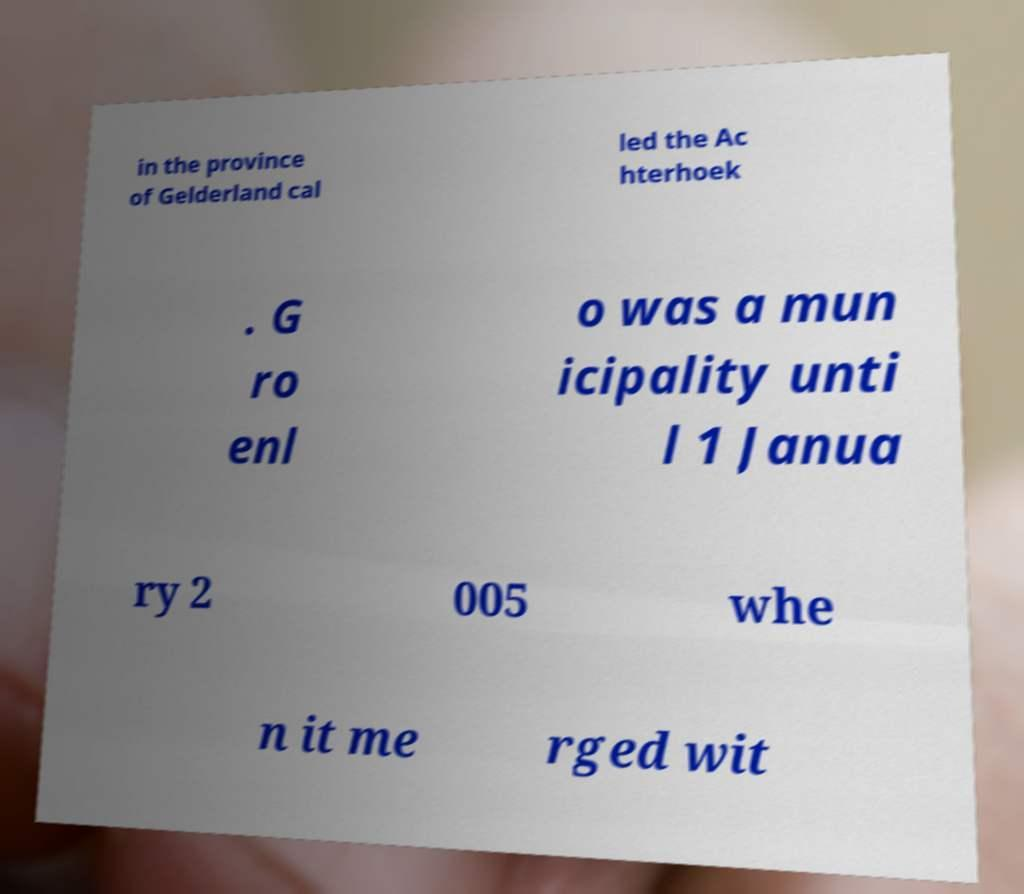Can you accurately transcribe the text from the provided image for me? in the province of Gelderland cal led the Ac hterhoek . G ro enl o was a mun icipality unti l 1 Janua ry 2 005 whe n it me rged wit 